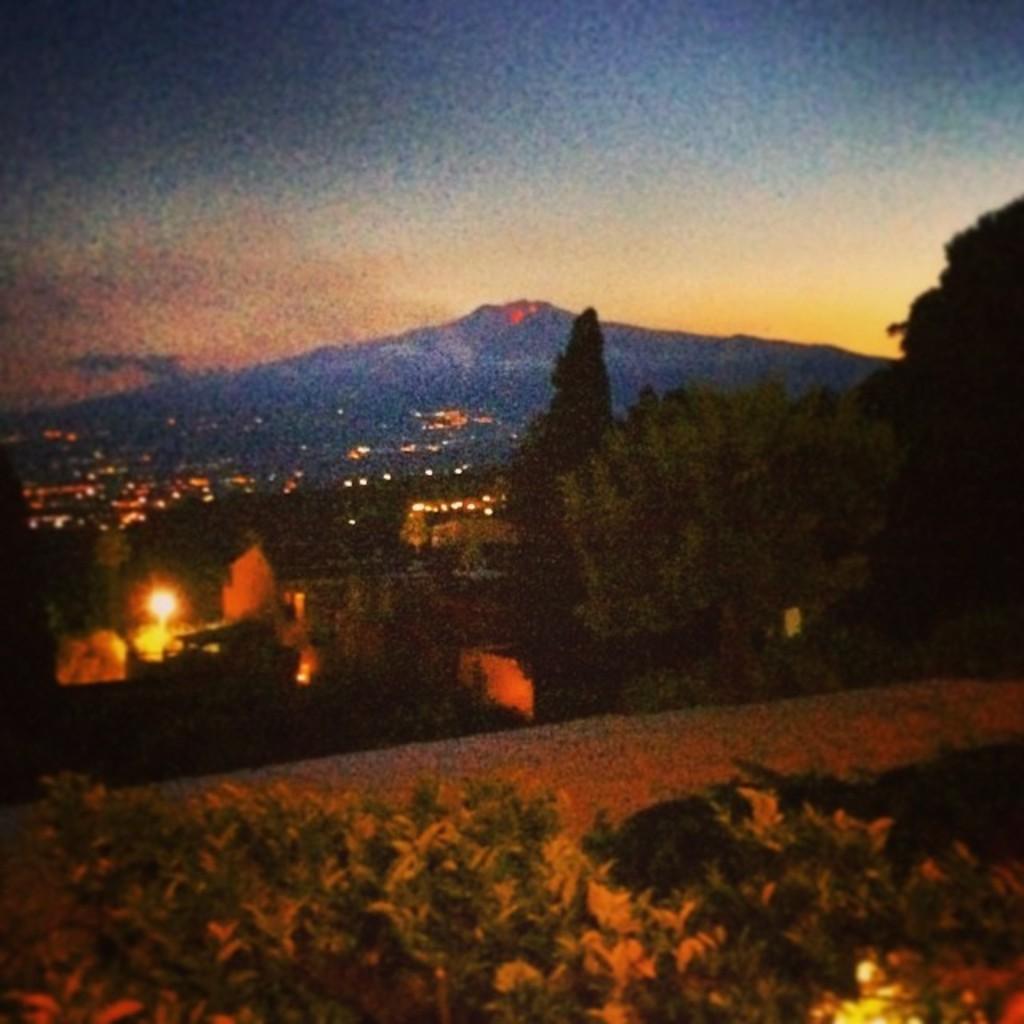Please provide a concise description of this image. In the center of the image there are trees and buildings. We can see lights. At the bottom there are plants. In the background there is a hill and sky. 